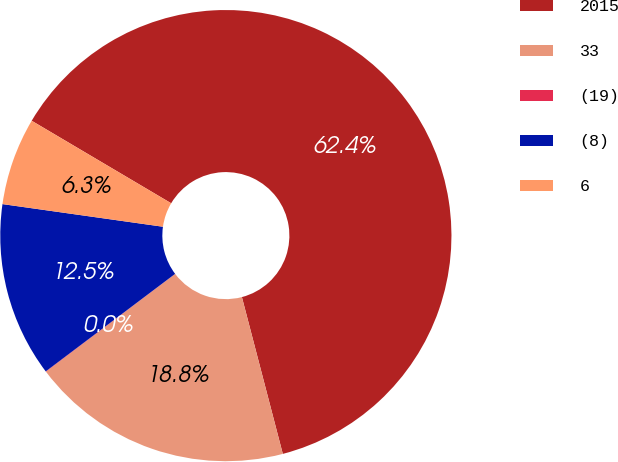<chart> <loc_0><loc_0><loc_500><loc_500><pie_chart><fcel>2015<fcel>33<fcel>(19)<fcel>(8)<fcel>6<nl><fcel>62.43%<fcel>18.75%<fcel>0.03%<fcel>12.51%<fcel>6.27%<nl></chart> 